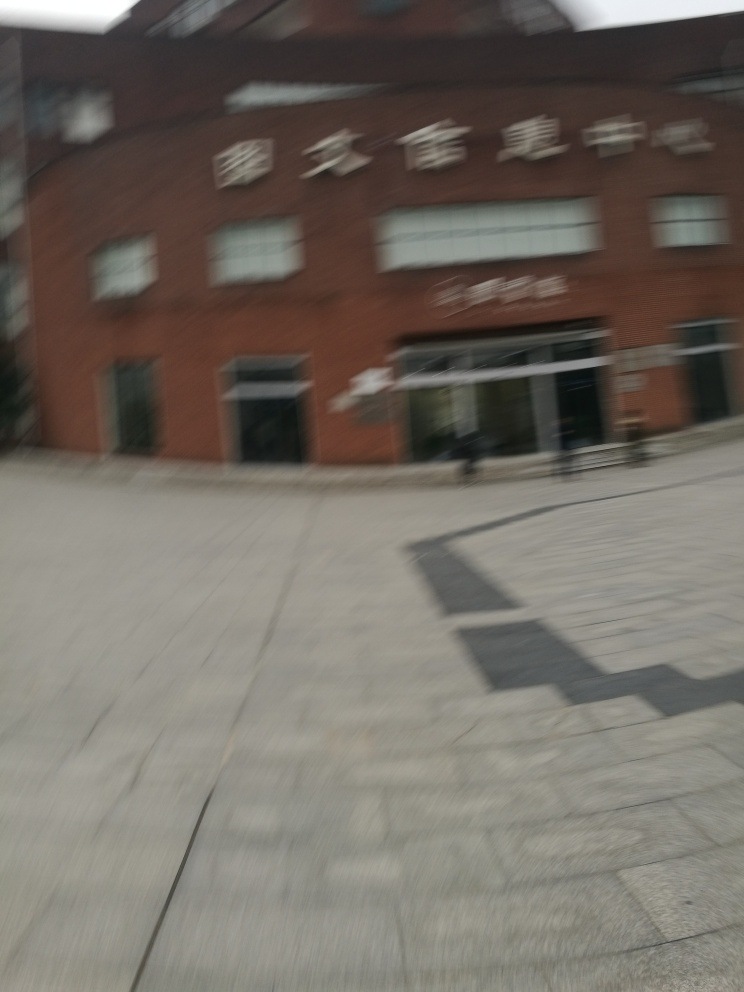Is there any visible activity around the building? The blurring makes it challenging to discern any detailed activity, but there don't seem to be many people around. This could indicate a time of day with lower foot traffic, or the photo was taken from a moving vehicle, capturing the scene without the clarity necessary to observe detailed activities. 